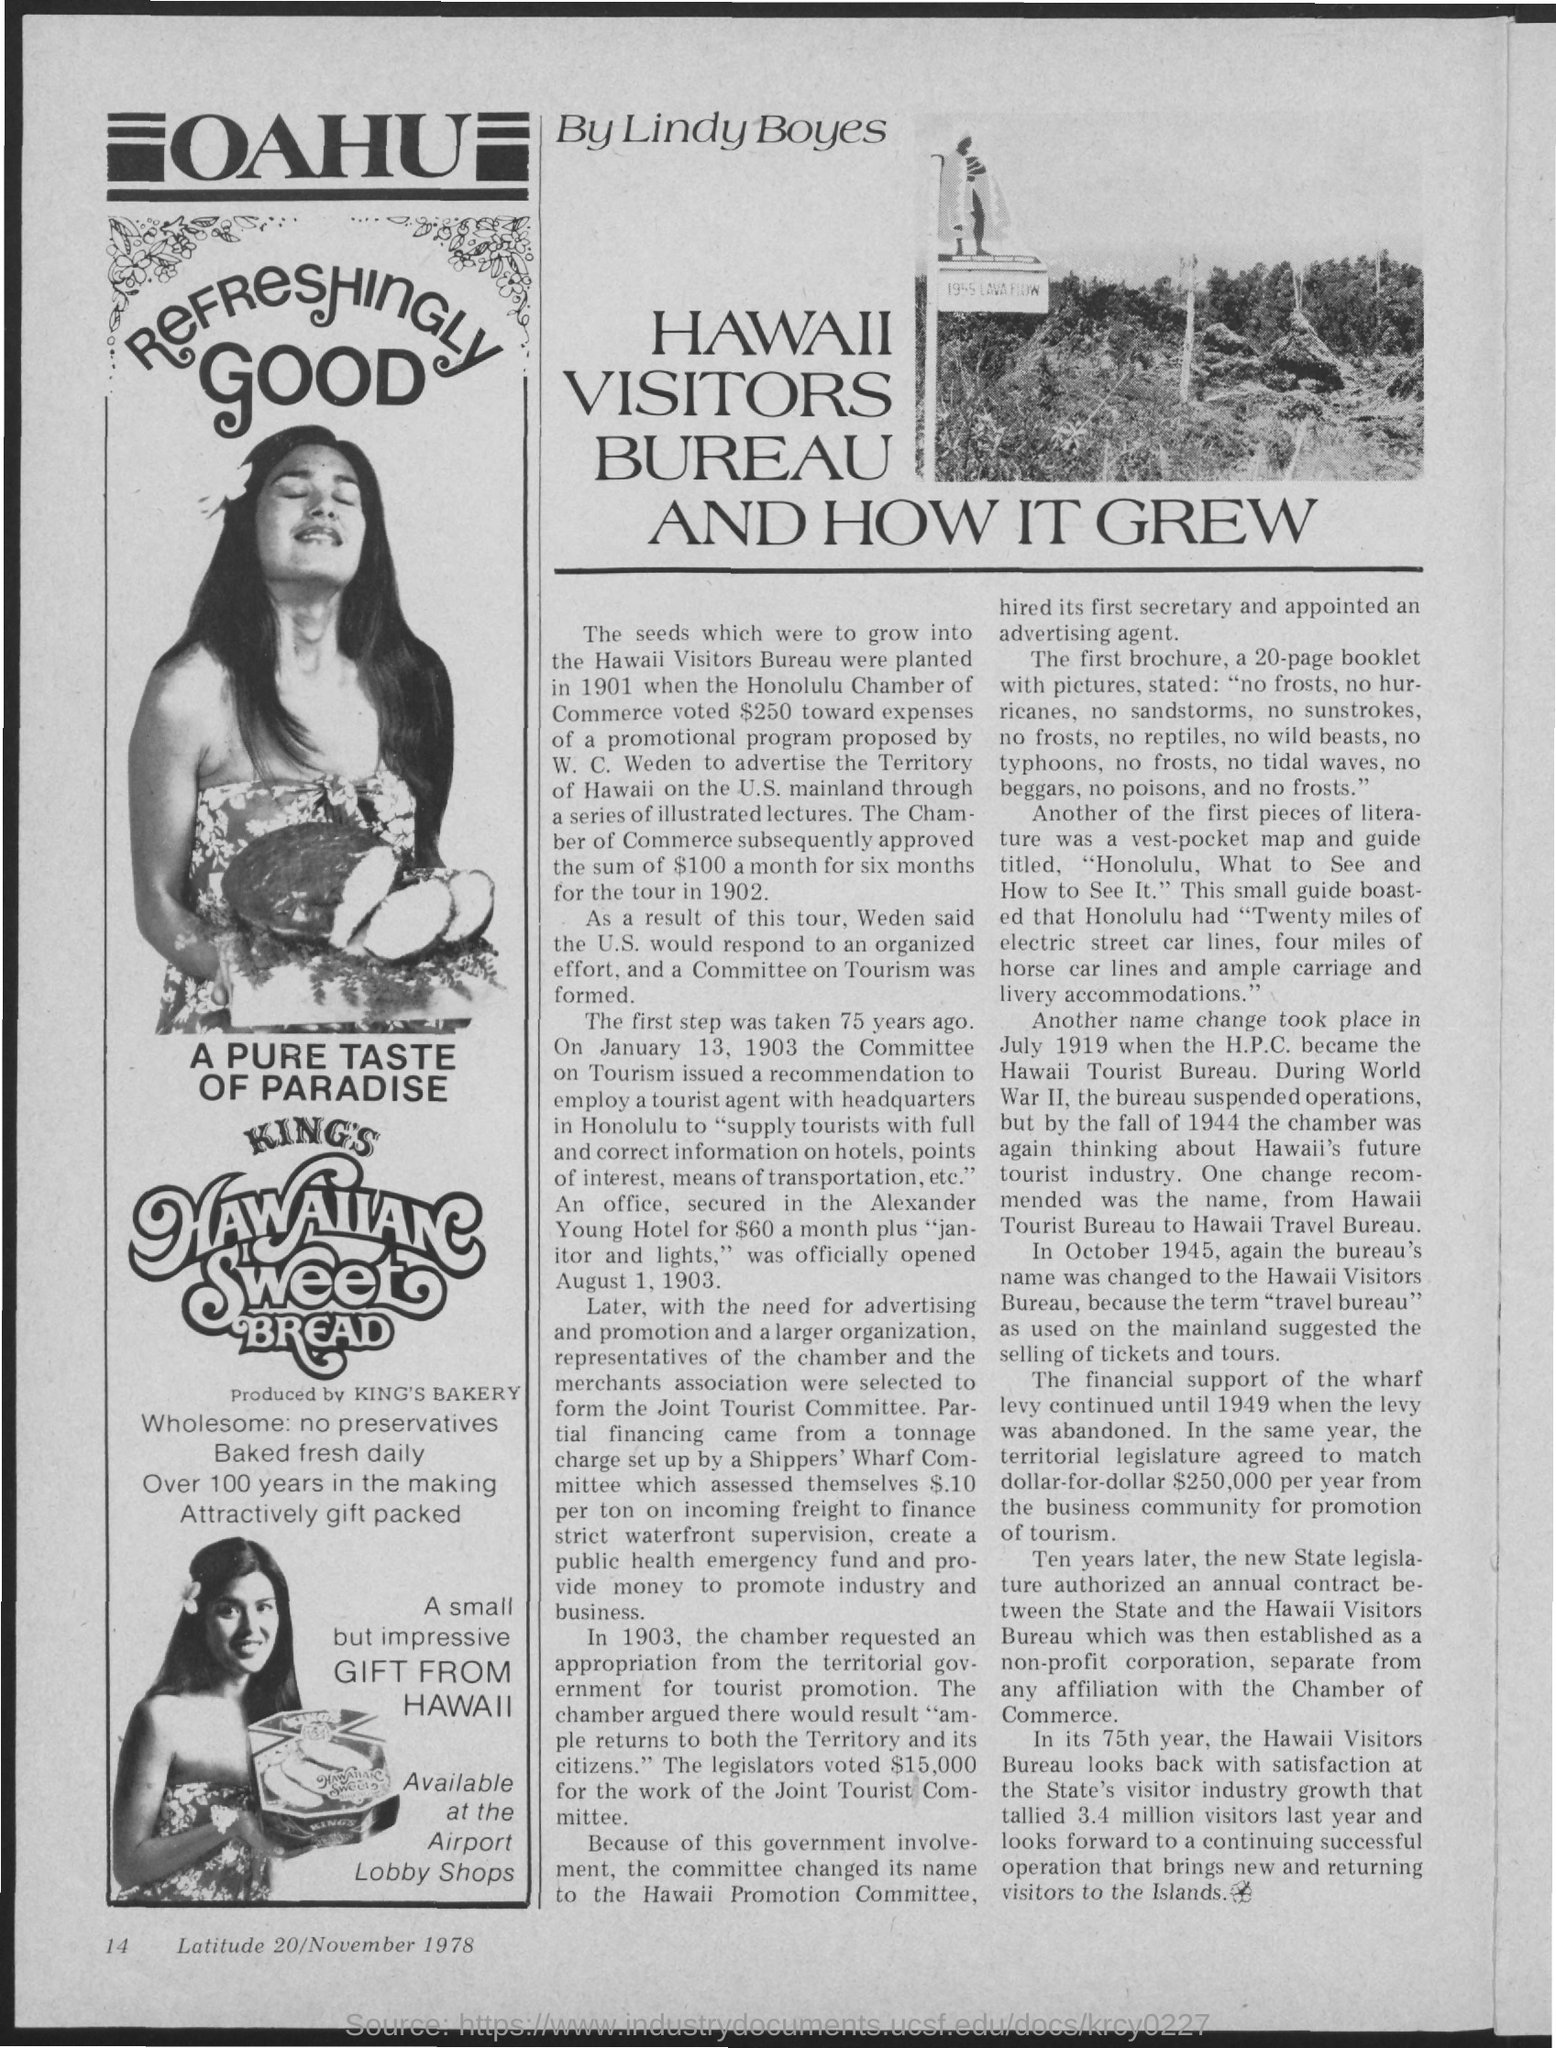What is the heading to left side of the page?
Give a very brief answer. OAHU. Who wrote this article?
Give a very brief answer. Lindy Boyes. Who produces king's hawaiian sweet bread?
Offer a terse response. King's Bakery. What is the page number at bottom of the page?
Keep it short and to the point. 14. What is the date at bottom of the page?
Your answer should be very brief. 20/November 1978. 